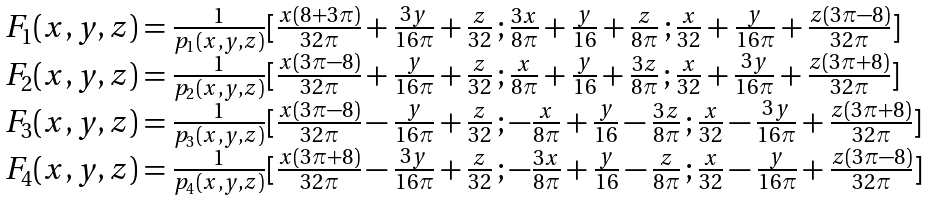Convert formula to latex. <formula><loc_0><loc_0><loc_500><loc_500>\begin{array} { l } F _ { 1 } ( x , y , z ) = \frac { 1 } { p _ { 1 } ( x , y , z ) } [ \frac { x ( 8 + 3 \pi ) } { 3 2 \pi } + \frac { 3 y } { 1 6 \pi } + \frac { z } { 3 2 } \, ; \frac { 3 x } { 8 \pi } + \frac { y } { 1 6 } + \frac { z } { 8 \pi } \, ; \frac { x } { 3 2 } + \frac { y } { 1 6 \pi } + \frac { z ( 3 \pi - 8 ) } { 3 2 \pi } ] \\ F _ { 2 } ( x , y , z ) = \frac { 1 } { p _ { 2 } ( x , y , z ) } [ \frac { x ( 3 \pi - 8 ) } { 3 2 \pi } + \frac { y } { 1 6 \pi } + \frac { z } { 3 2 } \, ; \frac { x } { 8 \pi } + \frac { y } { 1 6 } + \frac { 3 z } { 8 \pi } \, ; \frac { x } { 3 2 } + \frac { 3 y } { 1 6 \pi } + \frac { z ( 3 \pi + 8 ) } { 3 2 \pi } ] \\ F _ { 3 } ( x , y , z ) = \frac { 1 } { p _ { 3 } ( x , y , z ) } [ \frac { x ( 3 \pi - 8 ) } { 3 2 \pi } - \frac { y } { 1 6 \pi } + \frac { z } { 3 2 } \, ; - \frac { x } { 8 \pi } + \frac { y } { 1 6 } - \frac { 3 z } { 8 \pi } \, ; \frac { x } { 3 2 } - \frac { 3 y } { 1 6 \pi } + \frac { z ( 3 \pi + 8 ) } { 3 2 \pi } ] \\ F _ { 4 } ( x , y , z ) = \frac { 1 } { p _ { 4 } ( x , y , z ) } [ \frac { x ( 3 \pi + 8 ) } { 3 2 \pi } - \frac { 3 y } { 1 6 \pi } + \frac { z } { 3 2 } \, ; - \frac { 3 x } { 8 \pi } + \frac { y } { 1 6 } - \frac { z } { 8 \pi } \, ; \frac { x } { 3 2 } - \frac { y } { 1 6 \pi } + \frac { z ( 3 \pi - 8 ) } { 3 2 \pi } ] \\ \end{array}</formula> 